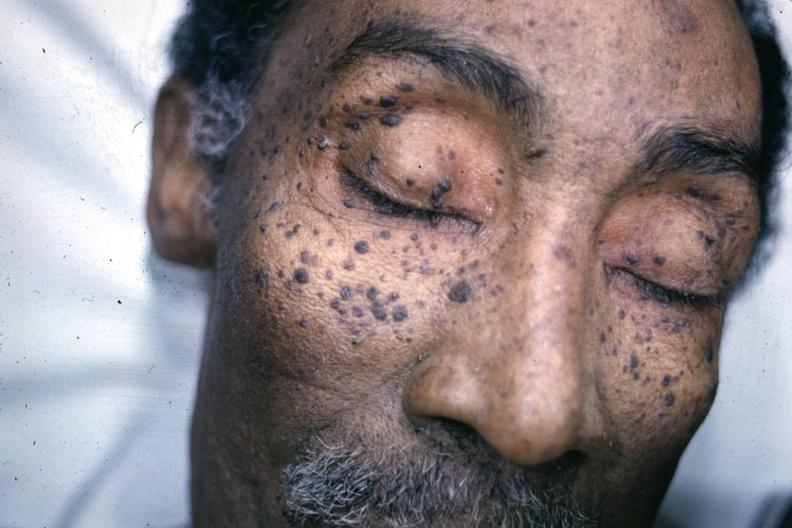s seborrheic keratosis present?
Answer the question using a single word or phrase. Yes 